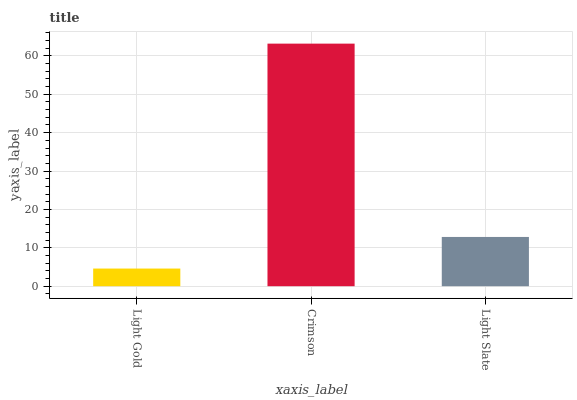Is Light Gold the minimum?
Answer yes or no. Yes. Is Crimson the maximum?
Answer yes or no. Yes. Is Light Slate the minimum?
Answer yes or no. No. Is Light Slate the maximum?
Answer yes or no. No. Is Crimson greater than Light Slate?
Answer yes or no. Yes. Is Light Slate less than Crimson?
Answer yes or no. Yes. Is Light Slate greater than Crimson?
Answer yes or no. No. Is Crimson less than Light Slate?
Answer yes or no. No. Is Light Slate the high median?
Answer yes or no. Yes. Is Light Slate the low median?
Answer yes or no. Yes. Is Light Gold the high median?
Answer yes or no. No. Is Crimson the low median?
Answer yes or no. No. 